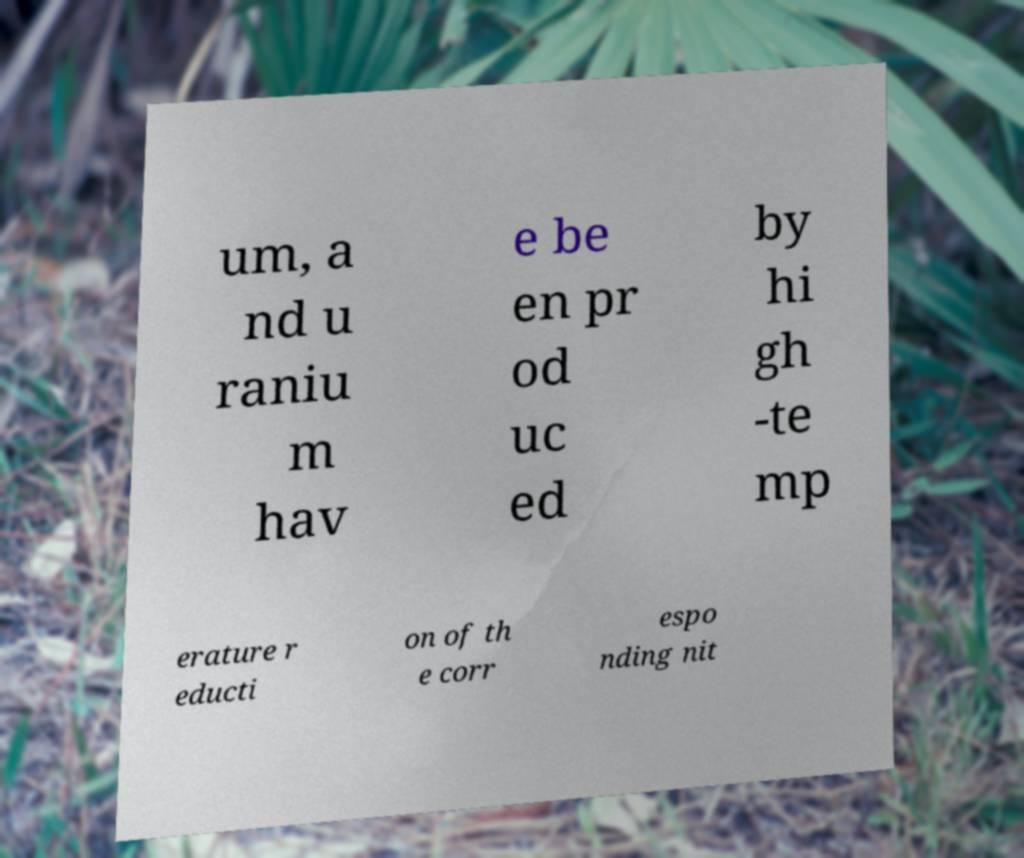Can you read and provide the text displayed in the image?This photo seems to have some interesting text. Can you extract and type it out for me? um, a nd u raniu m hav e be en pr od uc ed by hi gh -te mp erature r educti on of th e corr espo nding nit 